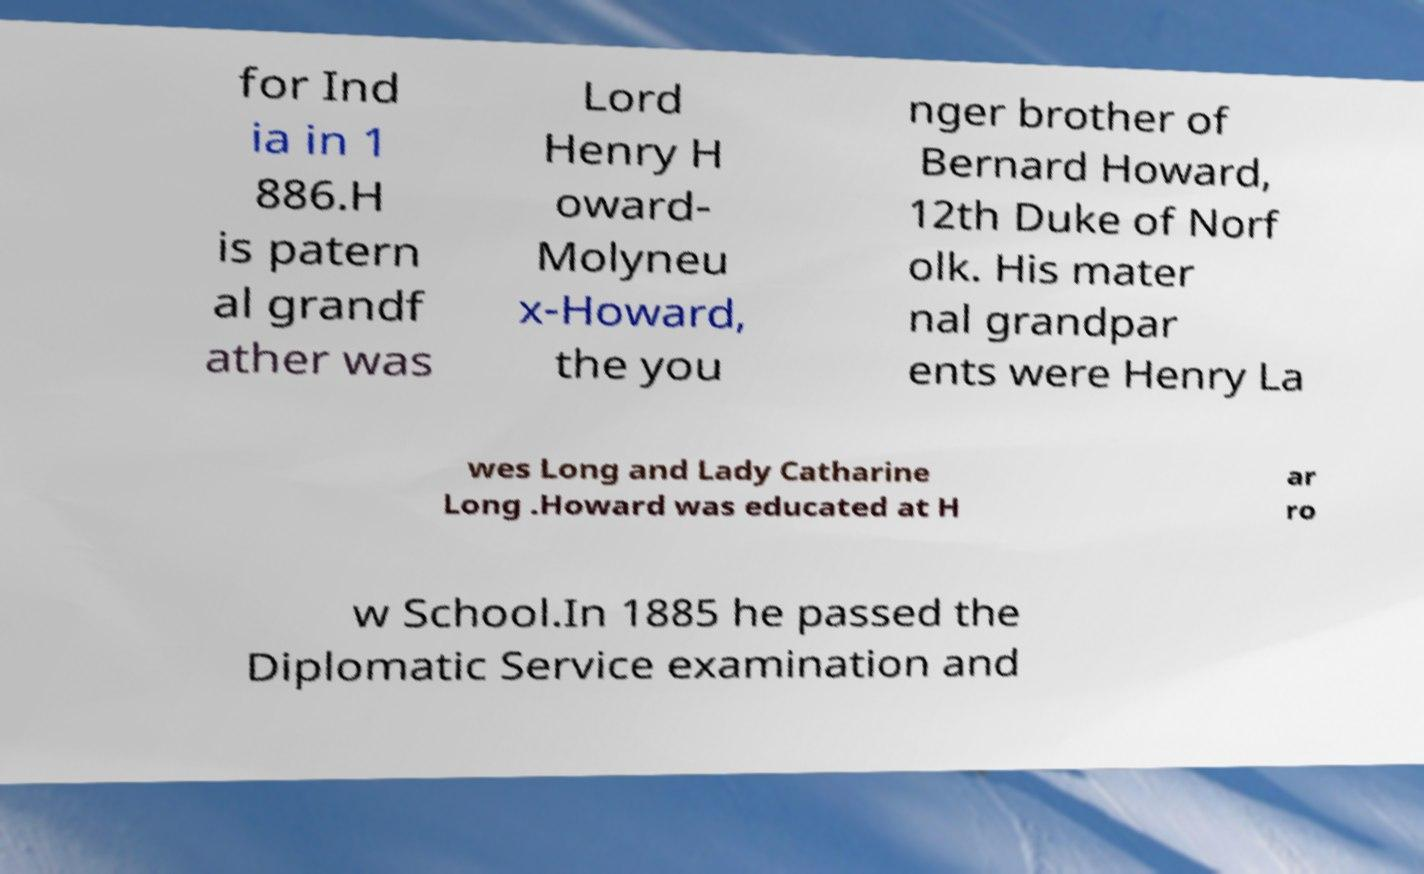I need the written content from this picture converted into text. Can you do that? for Ind ia in 1 886.H is patern al grandf ather was Lord Henry H oward- Molyneu x-Howard, the you nger brother of Bernard Howard, 12th Duke of Norf olk. His mater nal grandpar ents were Henry La wes Long and Lady Catharine Long .Howard was educated at H ar ro w School.In 1885 he passed the Diplomatic Service examination and 